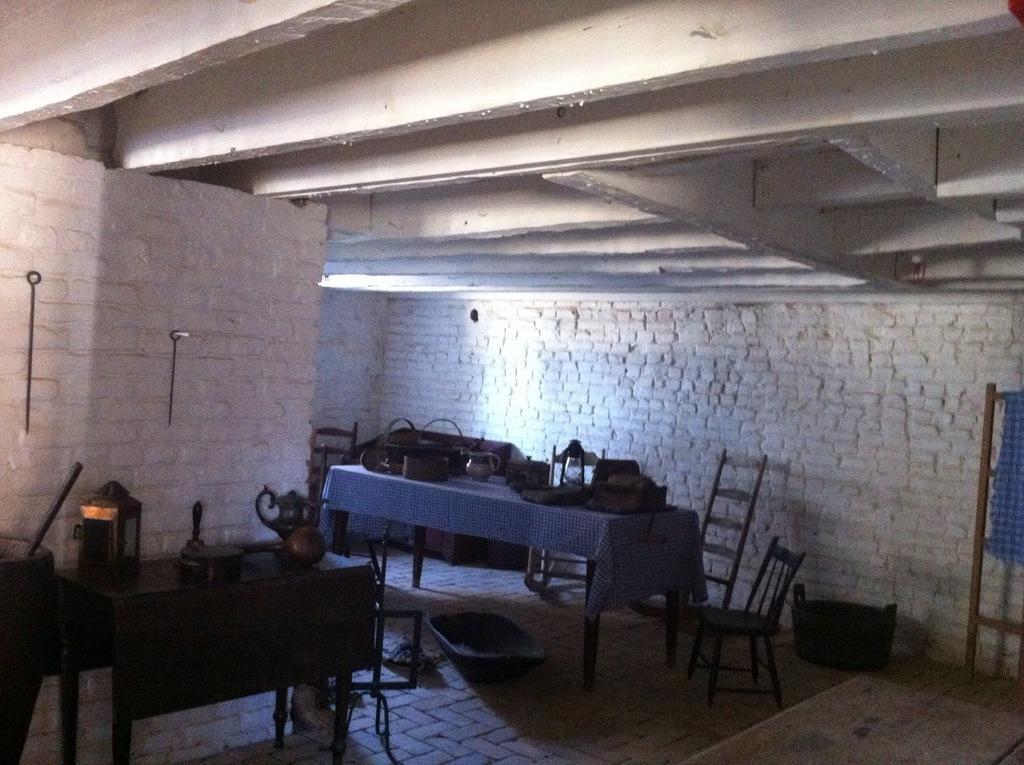Can you describe this image briefly? In this picture there is a table which has few objects placed on it and there is another table beside it which has some other objects placed on it and there are few chairs beside it and there is a brick wall which is in white color in the background. 